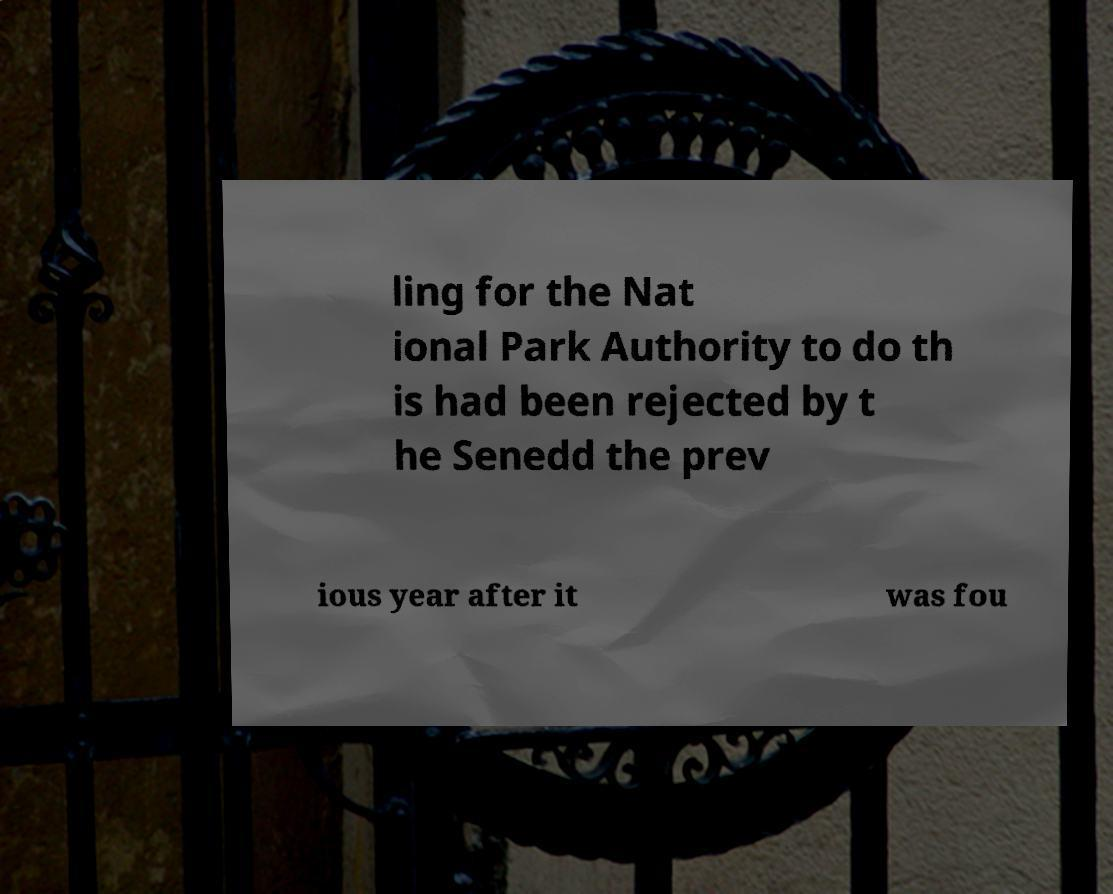Can you accurately transcribe the text from the provided image for me? ling for the Nat ional Park Authority to do th is had been rejected by t he Senedd the prev ious year after it was fou 